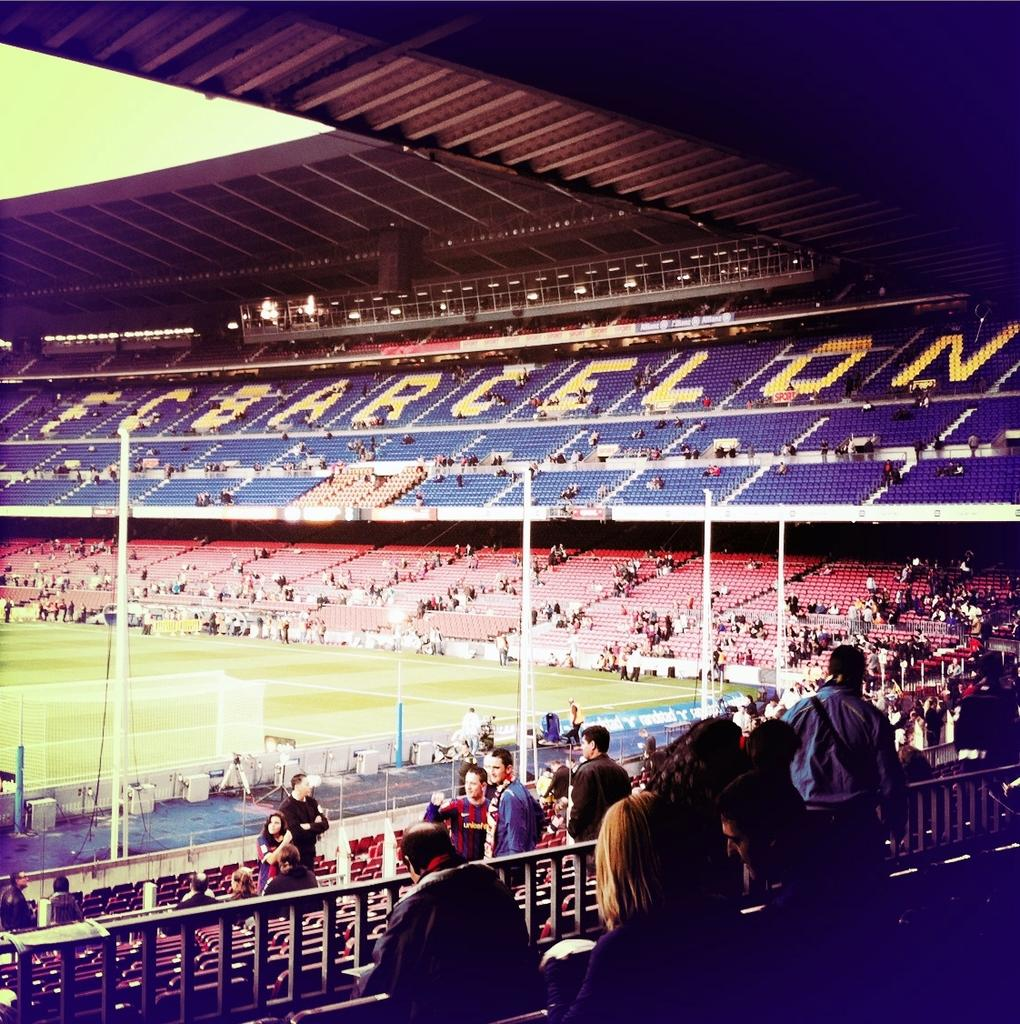Where was the image taken? The image was taken in a stadium. What can be seen happening at the bottom of the image? There are people moving around at the bottom of the image. What is located in the center of the image? There are poles in the center of the image. What type of surface is visible on the left side of the image? There is grass on the left side of the image. What is visible at the top of the image? There is a roof visible at the top of the image. What type of canvas is being stretched by the people at the bottom of the image? There is no canvas visible in the image; it is taken in a stadium with people moving around and poles in the center. 